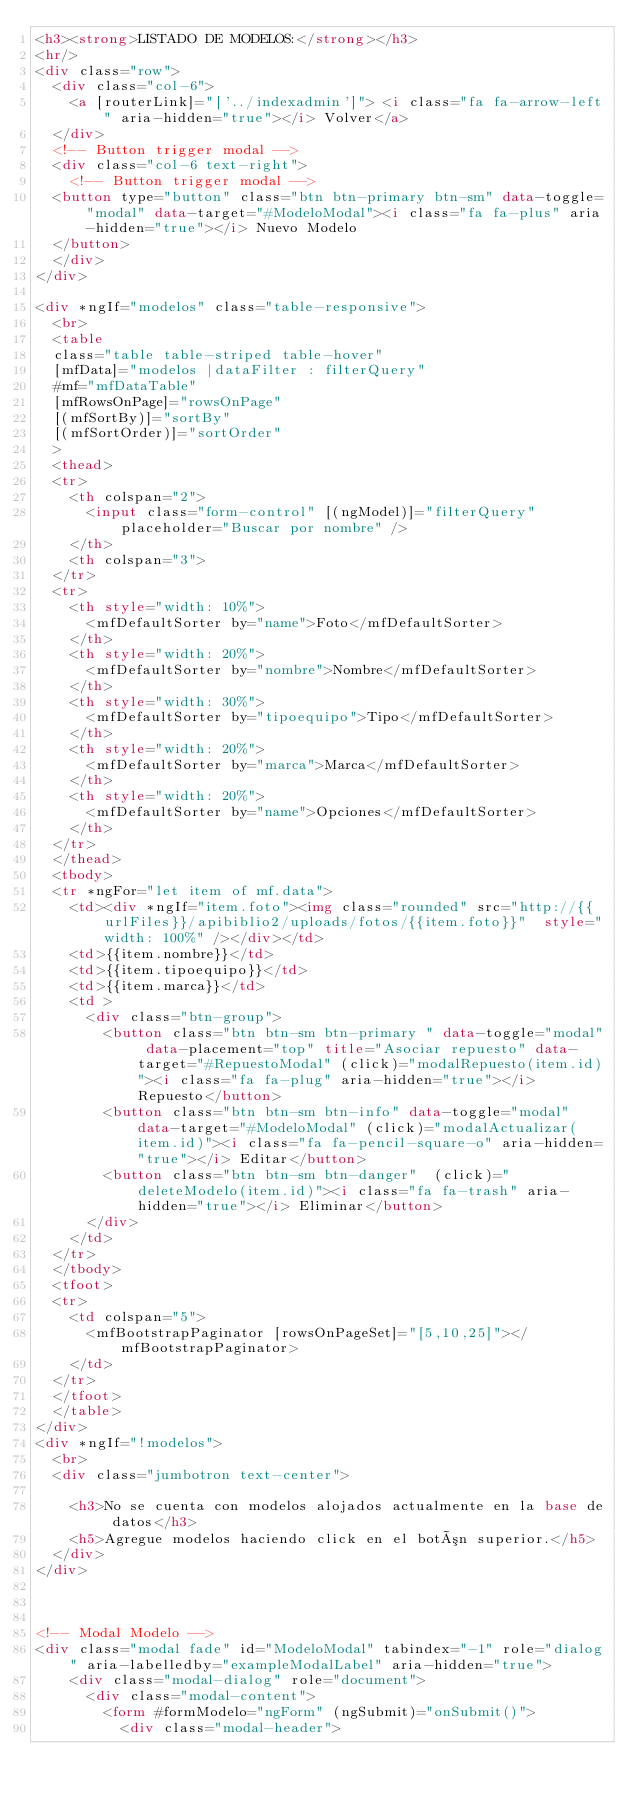<code> <loc_0><loc_0><loc_500><loc_500><_HTML_><h3><strong>LISTADO DE MODELOS:</strong></h3>
<hr/>
<div class="row">
  <div class="col-6">
    <a [routerLink]="['../indexadmin']"> <i class="fa fa-arrow-left" aria-hidden="true"></i> Volver</a>
  </div>
  <!-- Button trigger modal -->
  <div class="col-6 text-right">
    <!-- Button trigger modal -->
	<button type="button" class="btn btn-primary btn-sm" data-toggle="modal" data-target="#ModeloModal"><i class="fa fa-plus" aria-hidden="true"></i> Nuevo Modelo
	</button>
  </div>
</div>

<div *ngIf="modelos" class="table-responsive">
  <br>
  <table 
  class="table table-striped table-hover" 
  [mfData]="modelos |dataFilter : filterQuery" 
  #mf="mfDataTable" 
  [mfRowsOnPage]="rowsOnPage"
  [(mfSortBy)]="sortBy"
  [(mfSortOrder)]="sortOrder"
  >
  <thead>
  <tr>
    <th colspan="2">
      <input class="form-control" [(ngModel)]="filterQuery" placeholder="Buscar por nombre" />
    </th>
    <th colspan="3">
  </tr>
  <tr>
    <th style="width: 10%">
      <mfDefaultSorter by="name">Foto</mfDefaultSorter>
    </th>
    <th style="width: 20%">
      <mfDefaultSorter by="nombre">Nombre</mfDefaultSorter>
    </th>
    <th style="width: 30%">
      <mfDefaultSorter by="tipoequipo">Tipo</mfDefaultSorter>
    </th>
    <th style="width: 20%">
      <mfDefaultSorter by="marca">Marca</mfDefaultSorter>
    </th>
    <th style="width: 20%">
      <mfDefaultSorter by="name">Opciones</mfDefaultSorter>
    </th>
  </tr>
  </thead>
  <tbody>
  <tr *ngFor="let item of mf.data">
    <td><div *ngIf="item.foto"><img class="rounded" src="http://{{urlFiles}}/apibiblio2/uploads/fotos/{{item.foto}}"  style="width: 100%" /></div></td>
    <td>{{item.nombre}}</td>
    <td>{{item.tipoequipo}}</td>
    <td>{{item.marca}}</td>
    <td >
      <div class="btn-group">
        <button class="btn btn-sm btn-primary " data-toggle="modal" data-placement="top" title="Asociar repuesto" data-target="#RepuestoModal" (click)="modalRepuesto(item.id)"><i class="fa fa-plug" aria-hidden="true"></i> Repuesto</button>
        <button class="btn btn-sm btn-info" data-toggle="modal" data-target="#ModeloModal" (click)="modalActualizar(item.id)"><i class="fa fa-pencil-square-o" aria-hidden="true"></i> Editar</button>
        <button class="btn btn-sm btn-danger"  (click)="deleteModelo(item.id)"><i class="fa fa-trash" aria-hidden="true"></i> Eliminar</button>
      </div>
    </td>
  </tr>
  </tbody>
  <tfoot>
  <tr>
    <td colspan="5">
      <mfBootstrapPaginator [rowsOnPageSet]="[5,10,25]"></mfBootstrapPaginator>
    </td>
  </tr>
  </tfoot>
  </table>
</div>
<div *ngIf="!modelos">
  <br>
  <div class="jumbotron text-center">
    
    <h3>No se cuenta con modelos alojados actualmente en la base de datos</h3>
    <h5>Agregue modelos haciendo click en el botón superior.</h5>
  </div>
</div>



<!-- Modal Modelo -->
<div class="modal fade" id="ModeloModal" tabindex="-1" role="dialog" aria-labelledby="exampleModalLabel" aria-hidden="true">
  	<div class="modal-dialog" role="document">
	    <div class="modal-content">
	    	<form #formModelo="ngForm" (ngSubmit)="onSubmit()">
	      	<div class="modal-header"></code> 